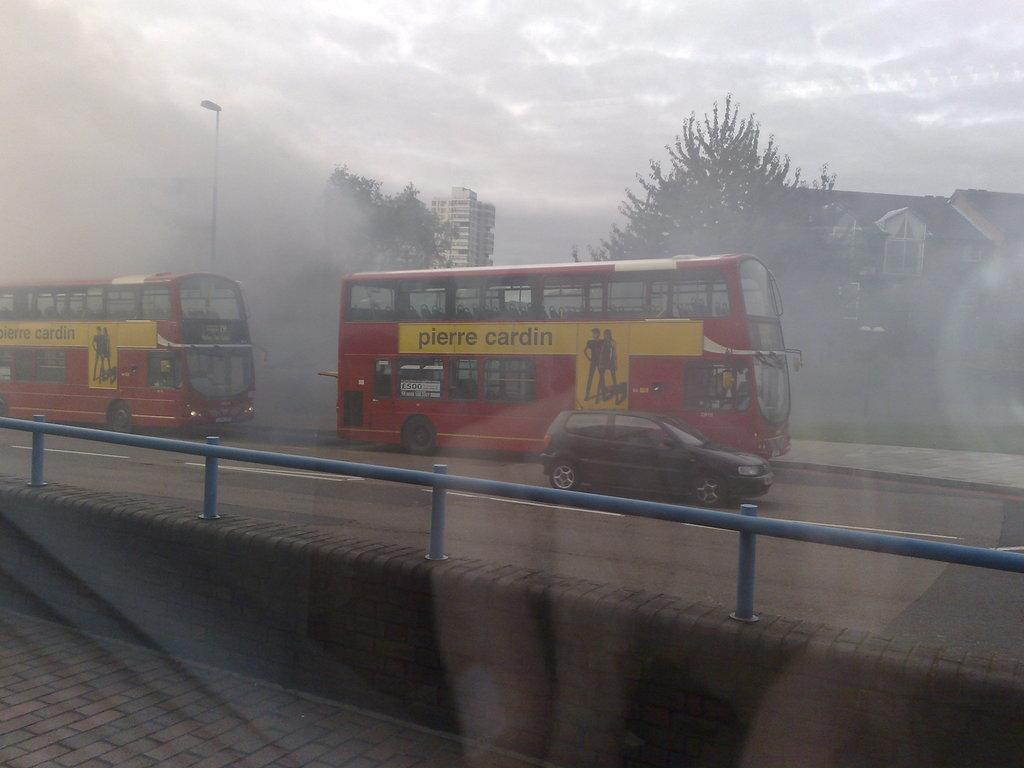<image>
Give a short and clear explanation of the subsequent image. The double decker buses are advertising Pierre Cardin. 